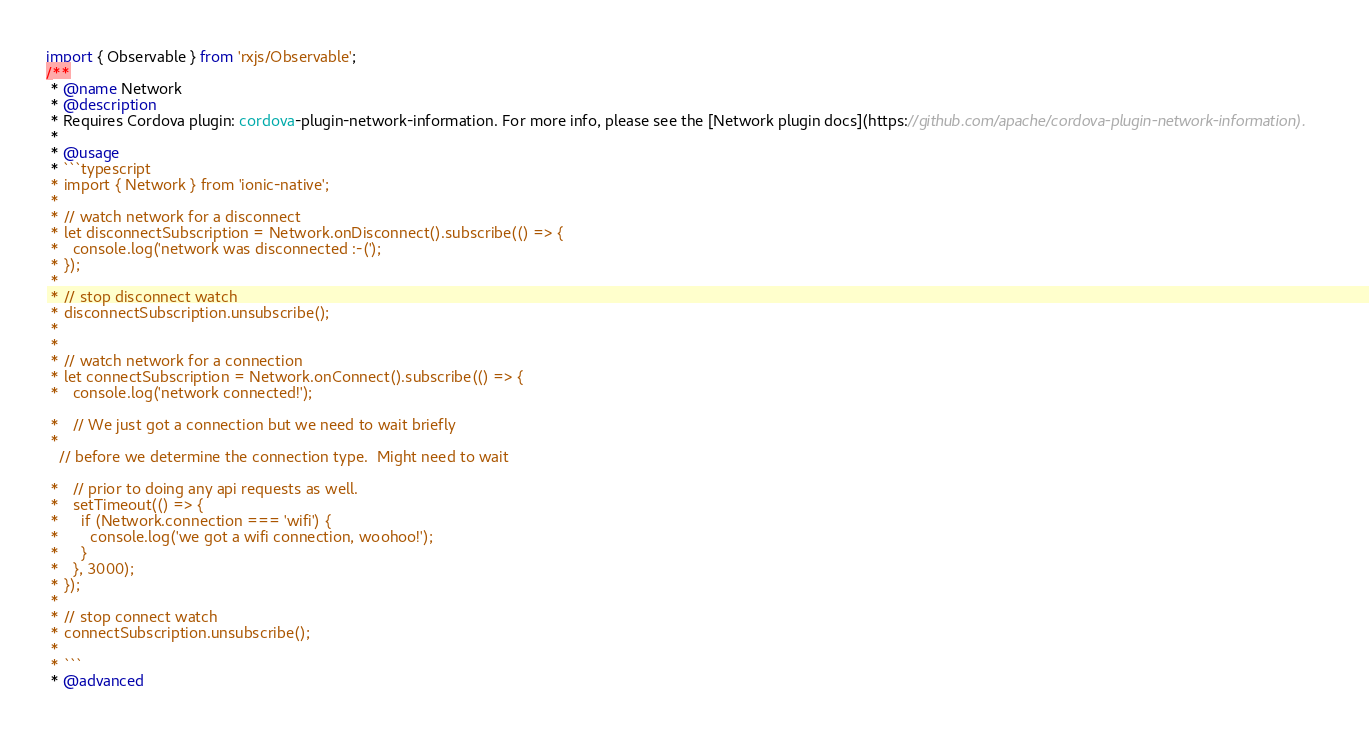Convert code to text. <code><loc_0><loc_0><loc_500><loc_500><_TypeScript_>import { Observable } from 'rxjs/Observable';
/**
 * @name Network
 * @description
 * Requires Cordova plugin: cordova-plugin-network-information. For more info, please see the [Network plugin docs](https://github.com/apache/cordova-plugin-network-information).
 *
 * @usage
 * ```typescript
 * import { Network } from 'ionic-native';
 *
 * // watch network for a disconnect
 * let disconnectSubscription = Network.onDisconnect().subscribe(() => {
 *   console.log('network was disconnected :-(');
 * });
 *
 * // stop disconnect watch
 * disconnectSubscription.unsubscribe();
 *
 *
 * // watch network for a connection
 * let connectSubscription = Network.onConnect().subscribe(() => {
 *   console.log('network connected!');

 *   // We just got a connection but we need to wait briefly
 *
   // before we determine the connection type.  Might need to wait

 *   // prior to doing any api requests as well.
 *   setTimeout(() => {
 *     if (Network.connection === 'wifi') {
 *       console.log('we got a wifi connection, woohoo!');
 *     }
 *   }, 3000);
 * });
 *
 * // stop connect watch
 * connectSubscription.unsubscribe();
 *
 * ```
 * @advanced</code> 